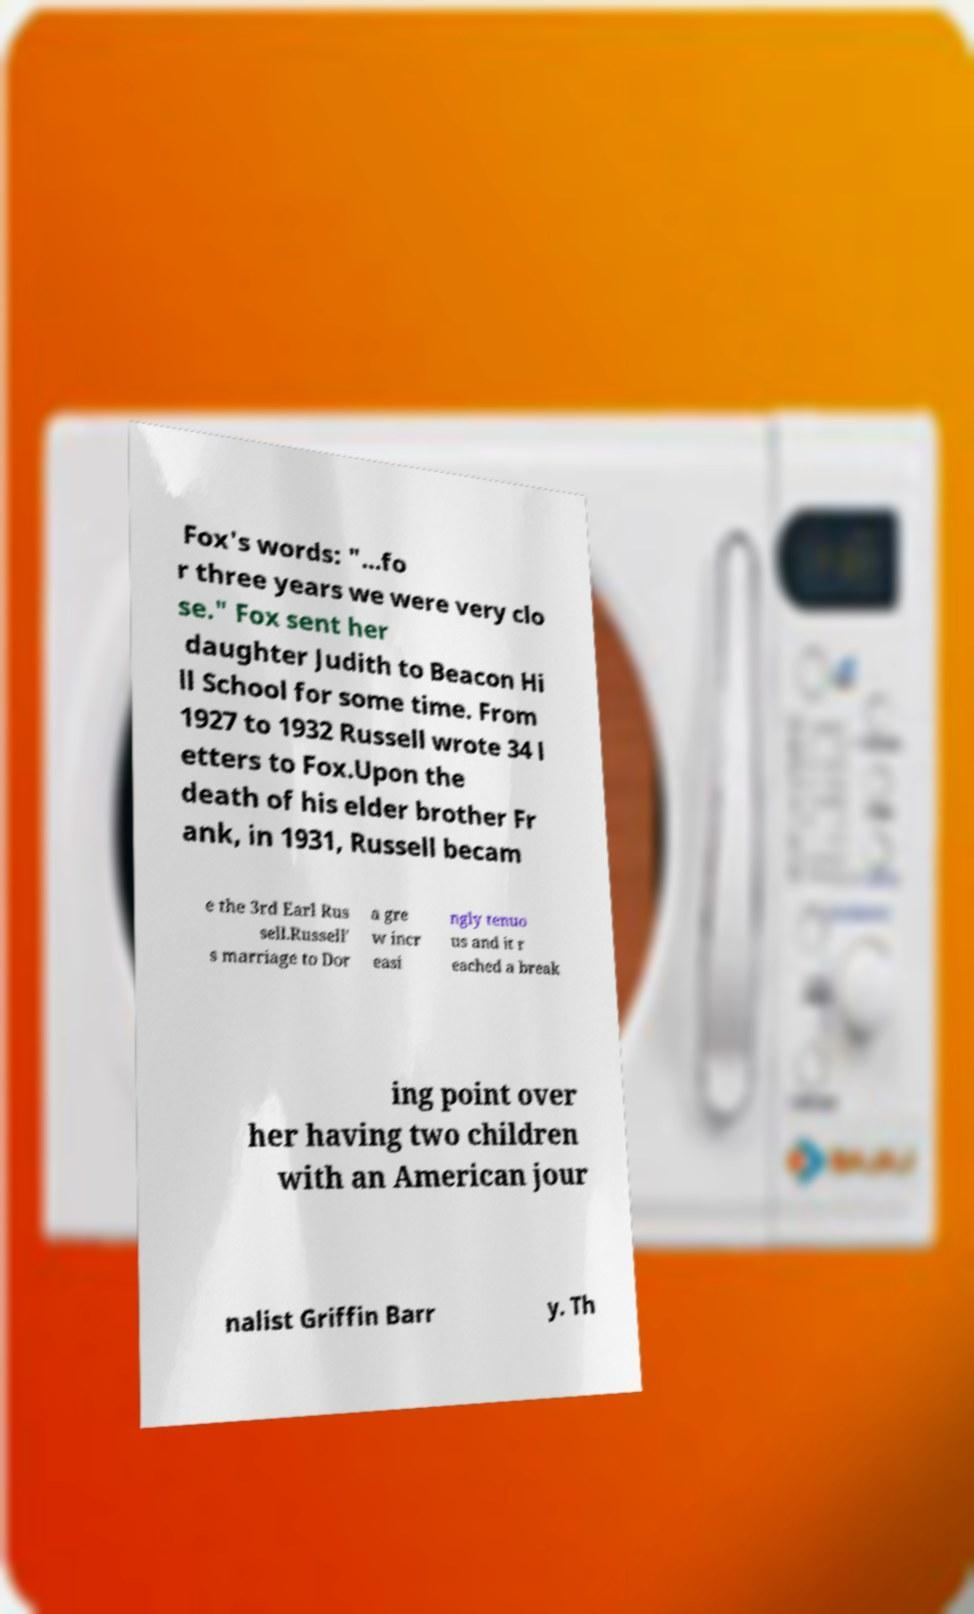There's text embedded in this image that I need extracted. Can you transcribe it verbatim? Fox's words: "...fo r three years we were very clo se." Fox sent her daughter Judith to Beacon Hi ll School for some time. From 1927 to 1932 Russell wrote 34 l etters to Fox.Upon the death of his elder brother Fr ank, in 1931, Russell becam e the 3rd Earl Rus sell.Russell' s marriage to Dor a gre w incr easi ngly tenuo us and it r eached a break ing point over her having two children with an American jour nalist Griffin Barr y. Th 